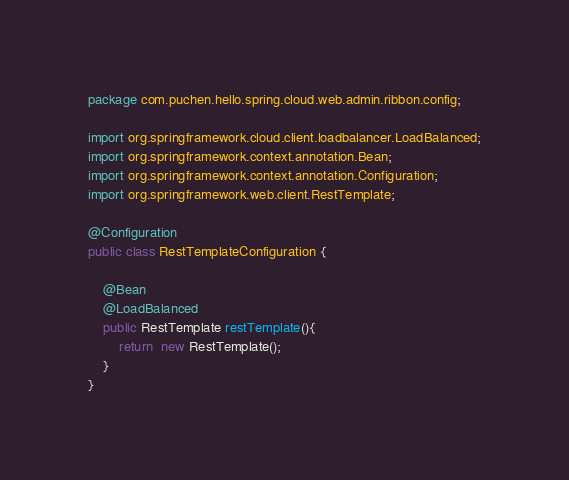<code> <loc_0><loc_0><loc_500><loc_500><_Java_>package com.puchen.hello.spring.cloud.web.admin.ribbon.config;

import org.springframework.cloud.client.loadbalancer.LoadBalanced;
import org.springframework.context.annotation.Bean;
import org.springframework.context.annotation.Configuration;
import org.springframework.web.client.RestTemplate;

@Configuration
public class RestTemplateConfiguration {

    @Bean
    @LoadBalanced
    public RestTemplate restTemplate(){
        return  new RestTemplate();
    }
}
</code> 